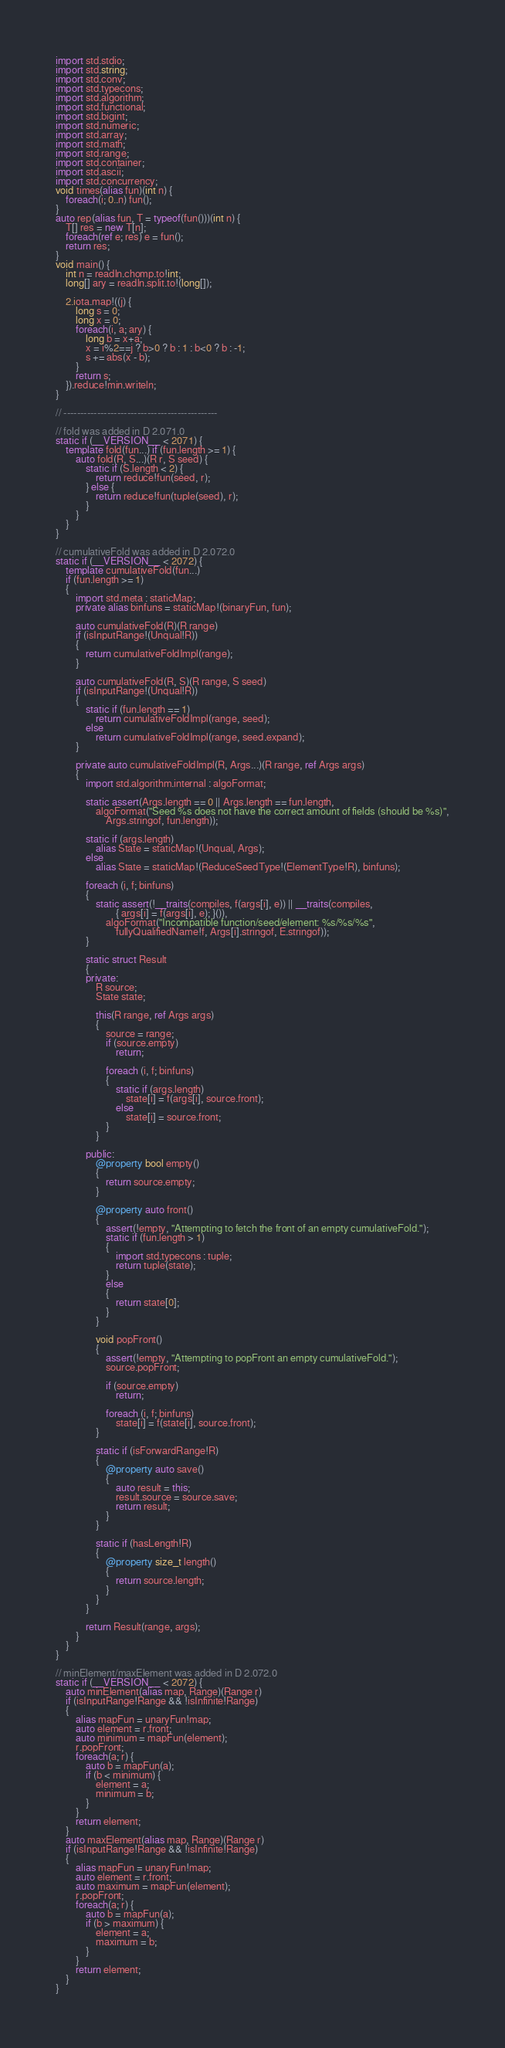<code> <loc_0><loc_0><loc_500><loc_500><_D_>import std.stdio;
import std.string;
import std.conv;
import std.typecons;
import std.algorithm;
import std.functional;
import std.bigint;
import std.numeric;
import std.array;
import std.math;
import std.range;
import std.container;
import std.ascii;
import std.concurrency;
void times(alias fun)(int n) {
    foreach(i; 0..n) fun();
}
auto rep(alias fun, T = typeof(fun()))(int n) {
    T[] res = new T[n];
    foreach(ref e; res) e = fun();
    return res;
}
void main() {
    int n = readln.chomp.to!int;
    long[] ary = readln.split.to!(long[]);

    2.iota.map!((j) {
        long s = 0;
        long x = 0;
        foreach(i, a; ary) {
            long b = x+a;
            x = i%2==j ? b>0 ? b : 1 : b<0 ? b : -1;
            s += abs(x - b);
        }
        return s;
    }).reduce!min.writeln;
}

// ----------------------------------------------

// fold was added in D 2.071.0
static if (__VERSION__ < 2071) {
    template fold(fun...) if (fun.length >= 1) {
        auto fold(R, S...)(R r, S seed) {
            static if (S.length < 2) {
                return reduce!fun(seed, r);
            } else {
                return reduce!fun(tuple(seed), r);
            }
        }
    }
}

// cumulativeFold was added in D 2.072.0
static if (__VERSION__ < 2072) {
    template cumulativeFold(fun...)
    if (fun.length >= 1)
    {
        import std.meta : staticMap;
        private alias binfuns = staticMap!(binaryFun, fun);

        auto cumulativeFold(R)(R range)
        if (isInputRange!(Unqual!R))
        {
            return cumulativeFoldImpl(range);
        }

        auto cumulativeFold(R, S)(R range, S seed)
        if (isInputRange!(Unqual!R))
        {
            static if (fun.length == 1)
                return cumulativeFoldImpl(range, seed);
            else
                return cumulativeFoldImpl(range, seed.expand);
        }

        private auto cumulativeFoldImpl(R, Args...)(R range, ref Args args)
        {
            import std.algorithm.internal : algoFormat;

            static assert(Args.length == 0 || Args.length == fun.length,
                algoFormat("Seed %s does not have the correct amount of fields (should be %s)",
                    Args.stringof, fun.length));

            static if (args.length)
                alias State = staticMap!(Unqual, Args);
            else
                alias State = staticMap!(ReduceSeedType!(ElementType!R), binfuns);

            foreach (i, f; binfuns)
            {
                static assert(!__traits(compiles, f(args[i], e)) || __traits(compiles,
                        { args[i] = f(args[i], e); }()),
                    algoFormat("Incompatible function/seed/element: %s/%s/%s",
                        fullyQualifiedName!f, Args[i].stringof, E.stringof));
            }

            static struct Result
            {
            private:
                R source;
                State state;

                this(R range, ref Args args)
                {
                    source = range;
                    if (source.empty)
                        return;

                    foreach (i, f; binfuns)
                    {
                        static if (args.length)
                            state[i] = f(args[i], source.front);
                        else
                            state[i] = source.front;
                    }
                }

            public:
                @property bool empty()
                {
                    return source.empty;
                }

                @property auto front()
                {
                    assert(!empty, "Attempting to fetch the front of an empty cumulativeFold.");
                    static if (fun.length > 1)
                    {
                        import std.typecons : tuple;
                        return tuple(state);
                    }
                    else
                    {
                        return state[0];
                    }
                }

                void popFront()
                {
                    assert(!empty, "Attempting to popFront an empty cumulativeFold.");
                    source.popFront;

                    if (source.empty)
                        return;

                    foreach (i, f; binfuns)
                        state[i] = f(state[i], source.front);
                }

                static if (isForwardRange!R)
                {
                    @property auto save()
                    {
                        auto result = this;
                        result.source = source.save;
                        return result;
                    }
                }

                static if (hasLength!R)
                {
                    @property size_t length()
                    {
                        return source.length;
                    }
                }
            }

            return Result(range, args);
        }
    }
}

// minElement/maxElement was added in D 2.072.0
static if (__VERSION__ < 2072) {
    auto minElement(alias map, Range)(Range r)
    if (isInputRange!Range && !isInfinite!Range)
    {
        alias mapFun = unaryFun!map;
        auto element = r.front;
        auto minimum = mapFun(element);
        r.popFront;
        foreach(a; r) {
            auto b = mapFun(a);
            if (b < minimum) {
                element = a;
                minimum = b;
            }
        }
        return element;
    }
    auto maxElement(alias map, Range)(Range r)
    if (isInputRange!Range && !isInfinite!Range)
    {
        alias mapFun = unaryFun!map;
        auto element = r.front;
        auto maximum = mapFun(element);
        r.popFront;
        foreach(a; r) {
            auto b = mapFun(a);
            if (b > maximum) {
                element = a;
                maximum = b;
            }
        }
        return element;
    }
}
</code> 